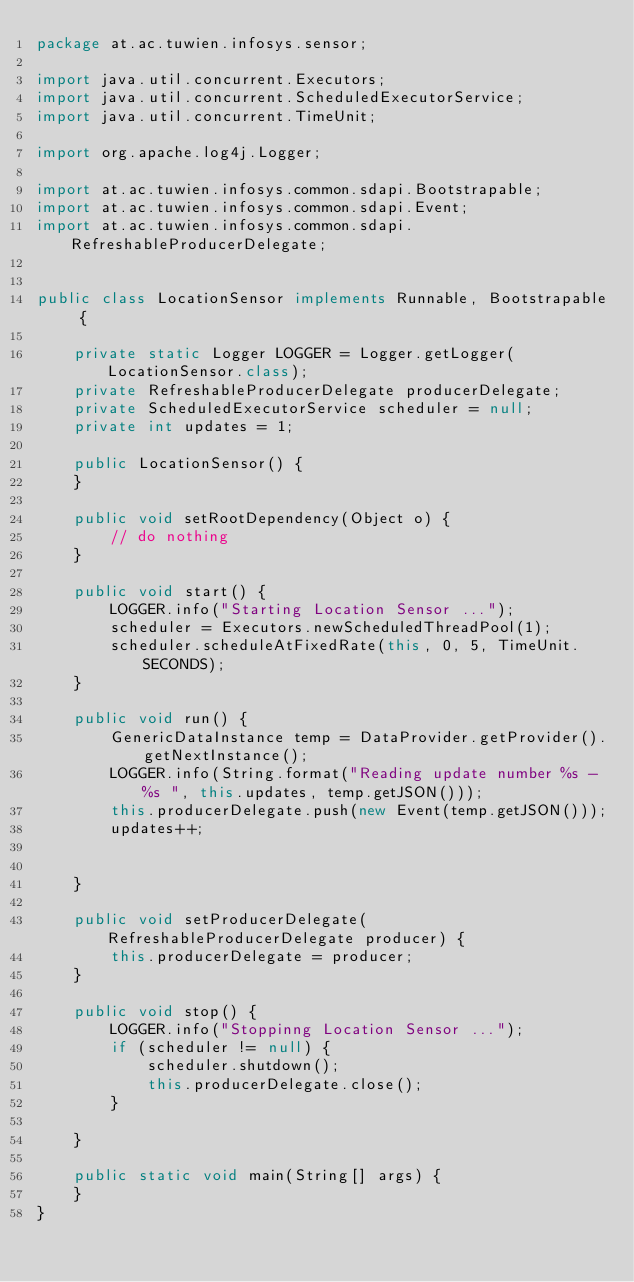<code> <loc_0><loc_0><loc_500><loc_500><_Java_>package at.ac.tuwien.infosys.sensor;

import java.util.concurrent.Executors;
import java.util.concurrent.ScheduledExecutorService;
import java.util.concurrent.TimeUnit;

import org.apache.log4j.Logger;

import at.ac.tuwien.infosys.common.sdapi.Bootstrapable;
import at.ac.tuwien.infosys.common.sdapi.Event;
import at.ac.tuwien.infosys.common.sdapi.RefreshableProducerDelegate;


public class LocationSensor implements Runnable, Bootstrapable {

	private static Logger LOGGER = Logger.getLogger(LocationSensor.class);
	private RefreshableProducerDelegate producerDelegate;
	private ScheduledExecutorService scheduler = null;
	private int updates = 1;

	public LocationSensor() {
	}

	public void setRootDependency(Object o) {
		// do nothing
	}

	public void start() {
		LOGGER.info("Starting Location Sensor ...");
		scheduler = Executors.newScheduledThreadPool(1);
		scheduler.scheduleAtFixedRate(this, 0, 5, TimeUnit.SECONDS);
	}

	public void run() {
		GenericDataInstance temp = DataProvider.getProvider().getNextInstance();
		LOGGER.info(String.format("Reading update number %s - %s ", this.updates, temp.getJSON()));
		this.producerDelegate.push(new Event(temp.getJSON()));
		updates++;
		

	}

	public void setProducerDelegate(RefreshableProducerDelegate producer) {
		this.producerDelegate = producer;
	}

	public void stop() {
		LOGGER.info("Stoppinng Location Sensor ...");
		if (scheduler != null) {
			scheduler.shutdown();
			this.producerDelegate.close();
		}

	}

	public static void main(String[] args) {
	}
}
</code> 